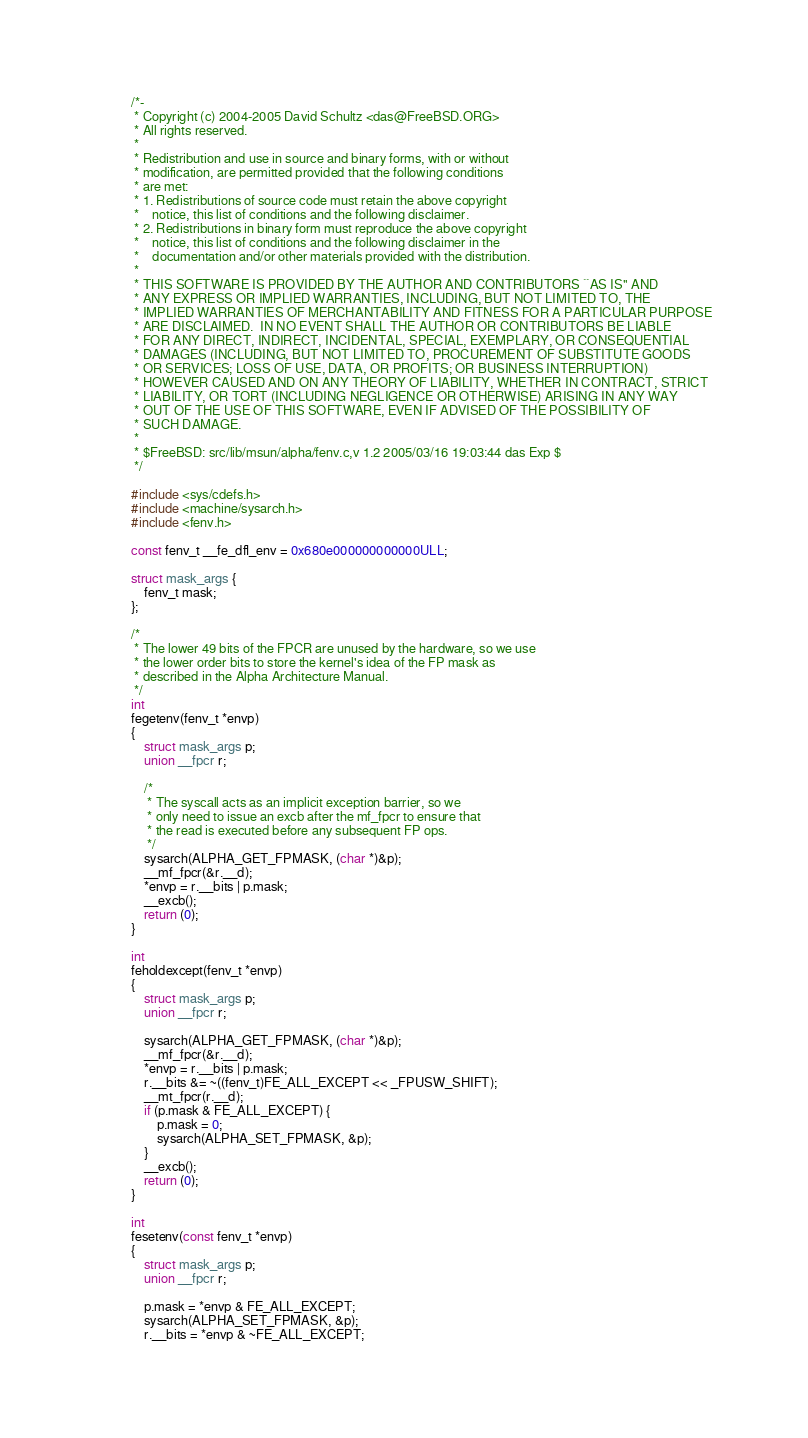Convert code to text. <code><loc_0><loc_0><loc_500><loc_500><_C_>/*-
 * Copyright (c) 2004-2005 David Schultz <das@FreeBSD.ORG>
 * All rights reserved.
 *
 * Redistribution and use in source and binary forms, with or without
 * modification, are permitted provided that the following conditions
 * are met:
 * 1. Redistributions of source code must retain the above copyright
 *    notice, this list of conditions and the following disclaimer.
 * 2. Redistributions in binary form must reproduce the above copyright
 *    notice, this list of conditions and the following disclaimer in the
 *    documentation and/or other materials provided with the distribution.
 *
 * THIS SOFTWARE IS PROVIDED BY THE AUTHOR AND CONTRIBUTORS ``AS IS'' AND
 * ANY EXPRESS OR IMPLIED WARRANTIES, INCLUDING, BUT NOT LIMITED TO, THE
 * IMPLIED WARRANTIES OF MERCHANTABILITY AND FITNESS FOR A PARTICULAR PURPOSE
 * ARE DISCLAIMED.  IN NO EVENT SHALL THE AUTHOR OR CONTRIBUTORS BE LIABLE
 * FOR ANY DIRECT, INDIRECT, INCIDENTAL, SPECIAL, EXEMPLARY, OR CONSEQUENTIAL
 * DAMAGES (INCLUDING, BUT NOT LIMITED TO, PROCUREMENT OF SUBSTITUTE GOODS
 * OR SERVICES; LOSS OF USE, DATA, OR PROFITS; OR BUSINESS INTERRUPTION)
 * HOWEVER CAUSED AND ON ANY THEORY OF LIABILITY, WHETHER IN CONTRACT, STRICT
 * LIABILITY, OR TORT (INCLUDING NEGLIGENCE OR OTHERWISE) ARISING IN ANY WAY
 * OUT OF THE USE OF THIS SOFTWARE, EVEN IF ADVISED OF THE POSSIBILITY OF
 * SUCH DAMAGE.
 *
 * $FreeBSD: src/lib/msun/alpha/fenv.c,v 1.2 2005/03/16 19:03:44 das Exp $
 */

#include <sys/cdefs.h>
#include <machine/sysarch.h>
#include <fenv.h>

const fenv_t __fe_dfl_env = 0x680e000000000000ULL;

struct mask_args {
	fenv_t mask;
};

/*
 * The lower 49 bits of the FPCR are unused by the hardware, so we use
 * the lower order bits to store the kernel's idea of the FP mask as
 * described in the Alpha Architecture Manual.
 */
int
fegetenv(fenv_t *envp)
{
	struct mask_args p;
	union __fpcr r;

	/*
	 * The syscall acts as an implicit exception barrier, so we
	 * only need to issue an excb after the mf_fpcr to ensure that
	 * the read is executed before any subsequent FP ops.
	 */
	sysarch(ALPHA_GET_FPMASK, (char *)&p);
	__mf_fpcr(&r.__d);
	*envp = r.__bits | p.mask;
	__excb();
	return (0);
}

int
feholdexcept(fenv_t *envp)
{
	struct mask_args p;
	union __fpcr r;

	sysarch(ALPHA_GET_FPMASK, (char *)&p);
	__mf_fpcr(&r.__d);
	*envp = r.__bits | p.mask;
	r.__bits &= ~((fenv_t)FE_ALL_EXCEPT << _FPUSW_SHIFT);
	__mt_fpcr(r.__d);
	if (p.mask & FE_ALL_EXCEPT) {
		p.mask = 0;
		sysarch(ALPHA_SET_FPMASK, &p);
	}
	__excb();
	return (0);
}

int
fesetenv(const fenv_t *envp)
{
	struct mask_args p;
	union __fpcr r;

	p.mask = *envp & FE_ALL_EXCEPT;
	sysarch(ALPHA_SET_FPMASK, &p);
	r.__bits = *envp & ~FE_ALL_EXCEPT;</code> 